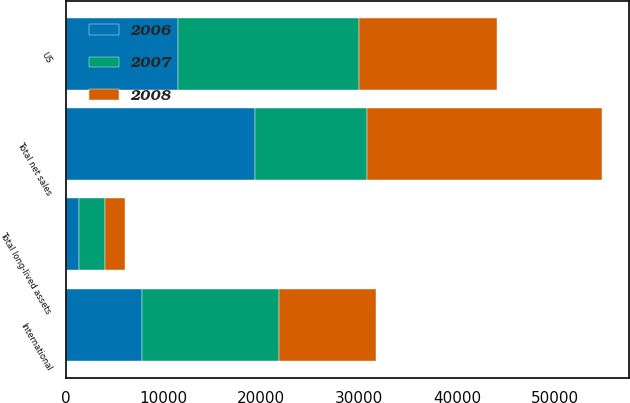<chart> <loc_0><loc_0><loc_500><loc_500><stacked_bar_chart><ecel><fcel>US<fcel>International<fcel>Total net sales<fcel>Total long-lived assets<nl><fcel>2007<fcel>18469<fcel>14010<fcel>11486<fcel>2679<nl><fcel>2008<fcel>14128<fcel>9878<fcel>24006<fcel>2012<nl><fcel>2006<fcel>11486<fcel>7829<fcel>19315<fcel>1368<nl></chart> 